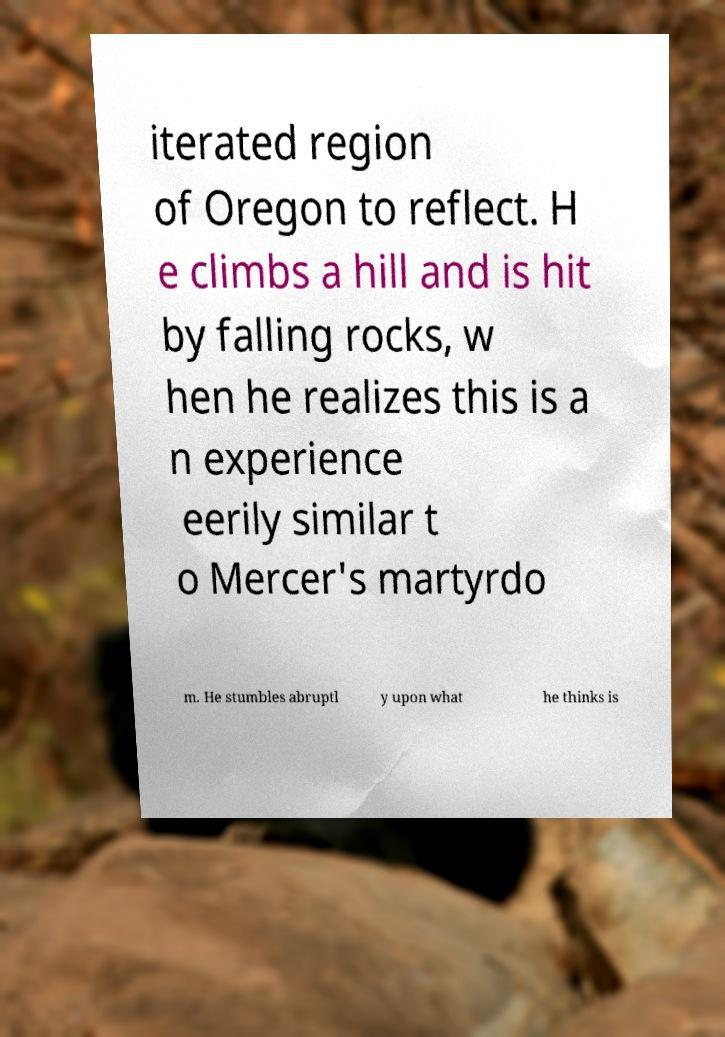I need the written content from this picture converted into text. Can you do that? iterated region of Oregon to reflect. H e climbs a hill and is hit by falling rocks, w hen he realizes this is a n experience eerily similar t o Mercer's martyrdo m. He stumbles abruptl y upon what he thinks is 